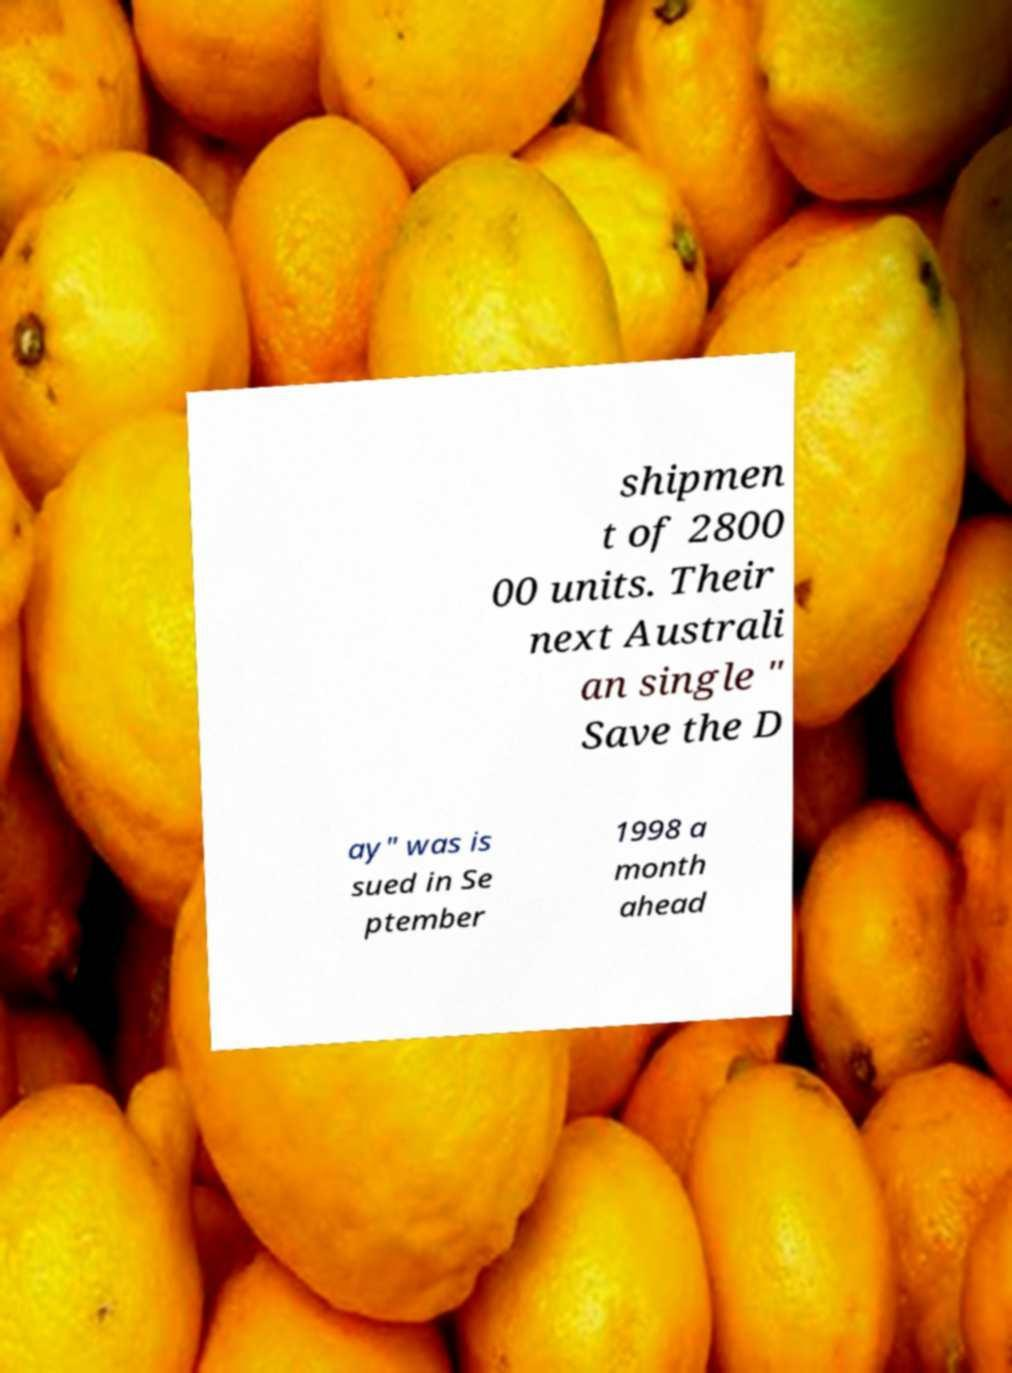Could you extract and type out the text from this image? shipmen t of 2800 00 units. Their next Australi an single " Save the D ay" was is sued in Se ptember 1998 a month ahead 